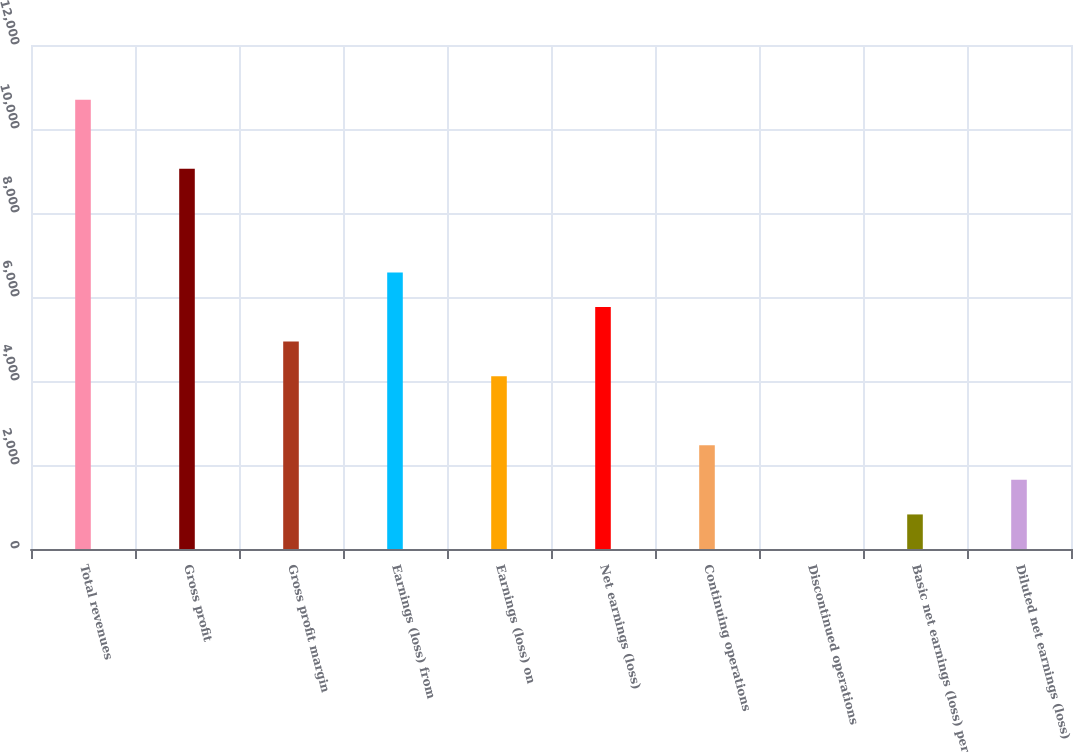Convert chart to OTSL. <chart><loc_0><loc_0><loc_500><loc_500><bar_chart><fcel>Total revenues<fcel>Gross profit<fcel>Gross profit margin<fcel>Earnings (loss) from<fcel>Earnings (loss) on<fcel>Net earnings (loss)<fcel>Continuing operations<fcel>Discontinued operations<fcel>Basic net earnings (loss) per<fcel>Diluted net earnings (loss)<nl><fcel>10698.1<fcel>9052.26<fcel>4937.61<fcel>6583.47<fcel>4114.68<fcel>5760.54<fcel>2468.82<fcel>0.03<fcel>822.96<fcel>1645.89<nl></chart> 